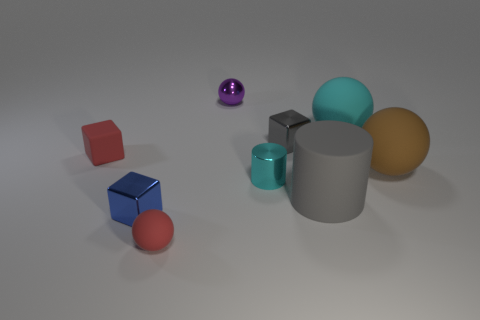Is there any other thing that is the same color as the tiny cylinder?
Ensure brevity in your answer.  Yes. There is a tiny red matte object to the left of the tiny matte object in front of the large rubber object in front of the brown ball; what is its shape?
Make the answer very short. Cube. The other tiny matte thing that is the same shape as the tiny gray thing is what color?
Make the answer very short. Red. There is a rubber sphere that is behind the shiny cube on the right side of the purple thing; what is its color?
Your answer should be compact. Cyan. What size is the matte object that is the same shape as the small cyan shiny object?
Your response must be concise. Large. What number of small blue blocks have the same material as the tiny gray thing?
Keep it short and to the point. 1. How many shiny cylinders are on the left side of the tiny red rubber object that is behind the big gray rubber cylinder?
Offer a terse response. 0. There is a tiny cylinder; are there any tiny matte things on the right side of it?
Ensure brevity in your answer.  No. Do the red thing in front of the big brown matte ball and the tiny gray metal thing have the same shape?
Offer a terse response. No. What is the material of the ball that is the same color as the small shiny cylinder?
Provide a succinct answer. Rubber. 